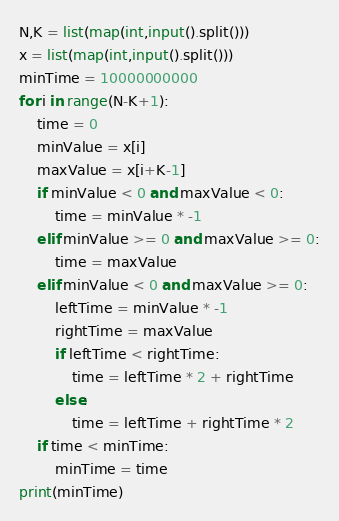<code> <loc_0><loc_0><loc_500><loc_500><_Python_>N,K = list(map(int,input().split()))
x = list(map(int,input().split()))
minTime = 10000000000
for i in range(N-K+1):
    time = 0
    minValue = x[i]
    maxValue = x[i+K-1]
    if minValue < 0 and maxValue < 0:
        time = minValue * -1
    elif minValue >= 0 and maxValue >= 0:
        time = maxValue
    elif minValue < 0 and maxValue >= 0:
        leftTime = minValue * -1
        rightTime = maxValue
        if leftTime < rightTime:
            time = leftTime * 2 + rightTime
        else:
            time = leftTime + rightTime * 2
    if time < minTime:
        minTime = time
print(minTime)</code> 